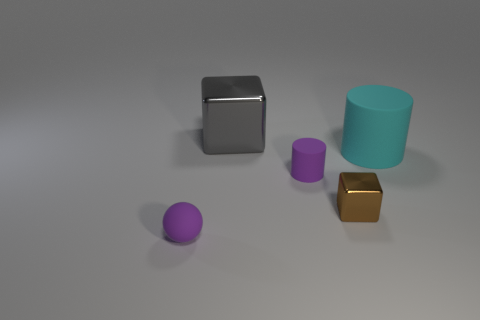There is a purple thing in front of the rubber cylinder left of the large cyan object; what is its material?
Provide a succinct answer. Rubber. Is there anything else that is the same shape as the small brown shiny thing?
Offer a very short reply. Yes. Do the brown metallic thing and the large thing left of the small brown cube have the same shape?
Your answer should be very brief. Yes. What size is the gray object that is the same shape as the tiny brown thing?
Provide a succinct answer. Large. What number of other objects are there of the same material as the cyan cylinder?
Your answer should be compact. 2. What is the material of the large gray thing?
Ensure brevity in your answer.  Metal. There is a cylinder left of the tiny brown block; is it the same color as the rubber object that is on the left side of the tiny purple rubber cylinder?
Provide a succinct answer. Yes. Is the number of matte objects to the right of the big gray shiny cube greater than the number of big cyan cylinders?
Your answer should be very brief. Yes. How many other things are there of the same color as the big metallic cube?
Keep it short and to the point. 0. Do the metal object that is behind the brown object and the purple matte ball have the same size?
Provide a short and direct response. No. 